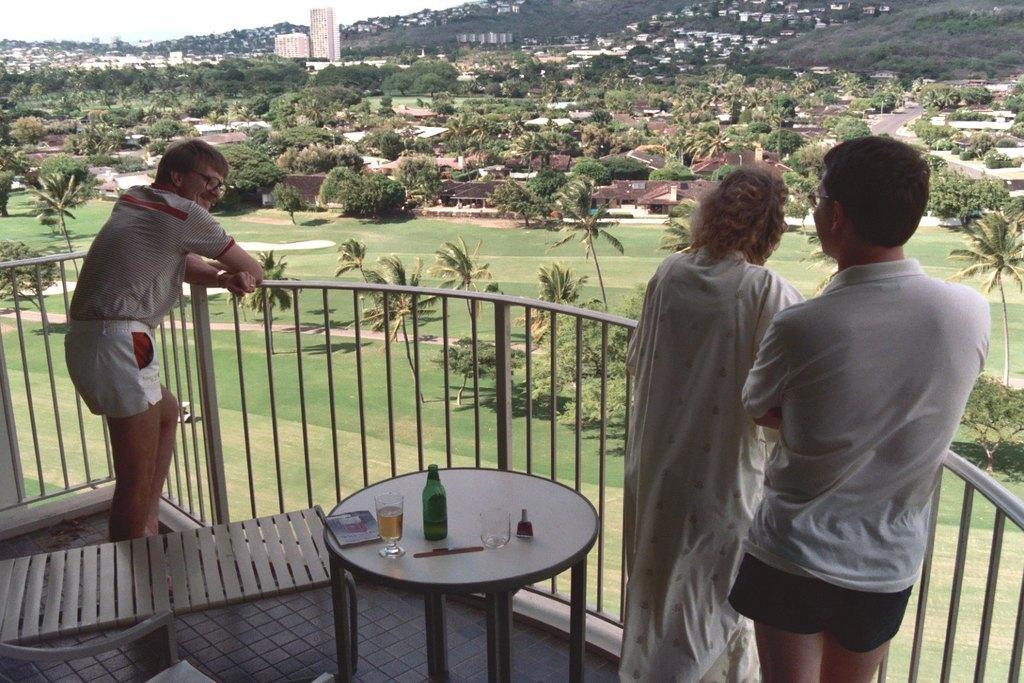Can you describe this image briefly? There are three members standing near the railing. Behind them there is a bench and a table on which a bottle, glass were placed. In the background there are some houses, trees and a hill here. 